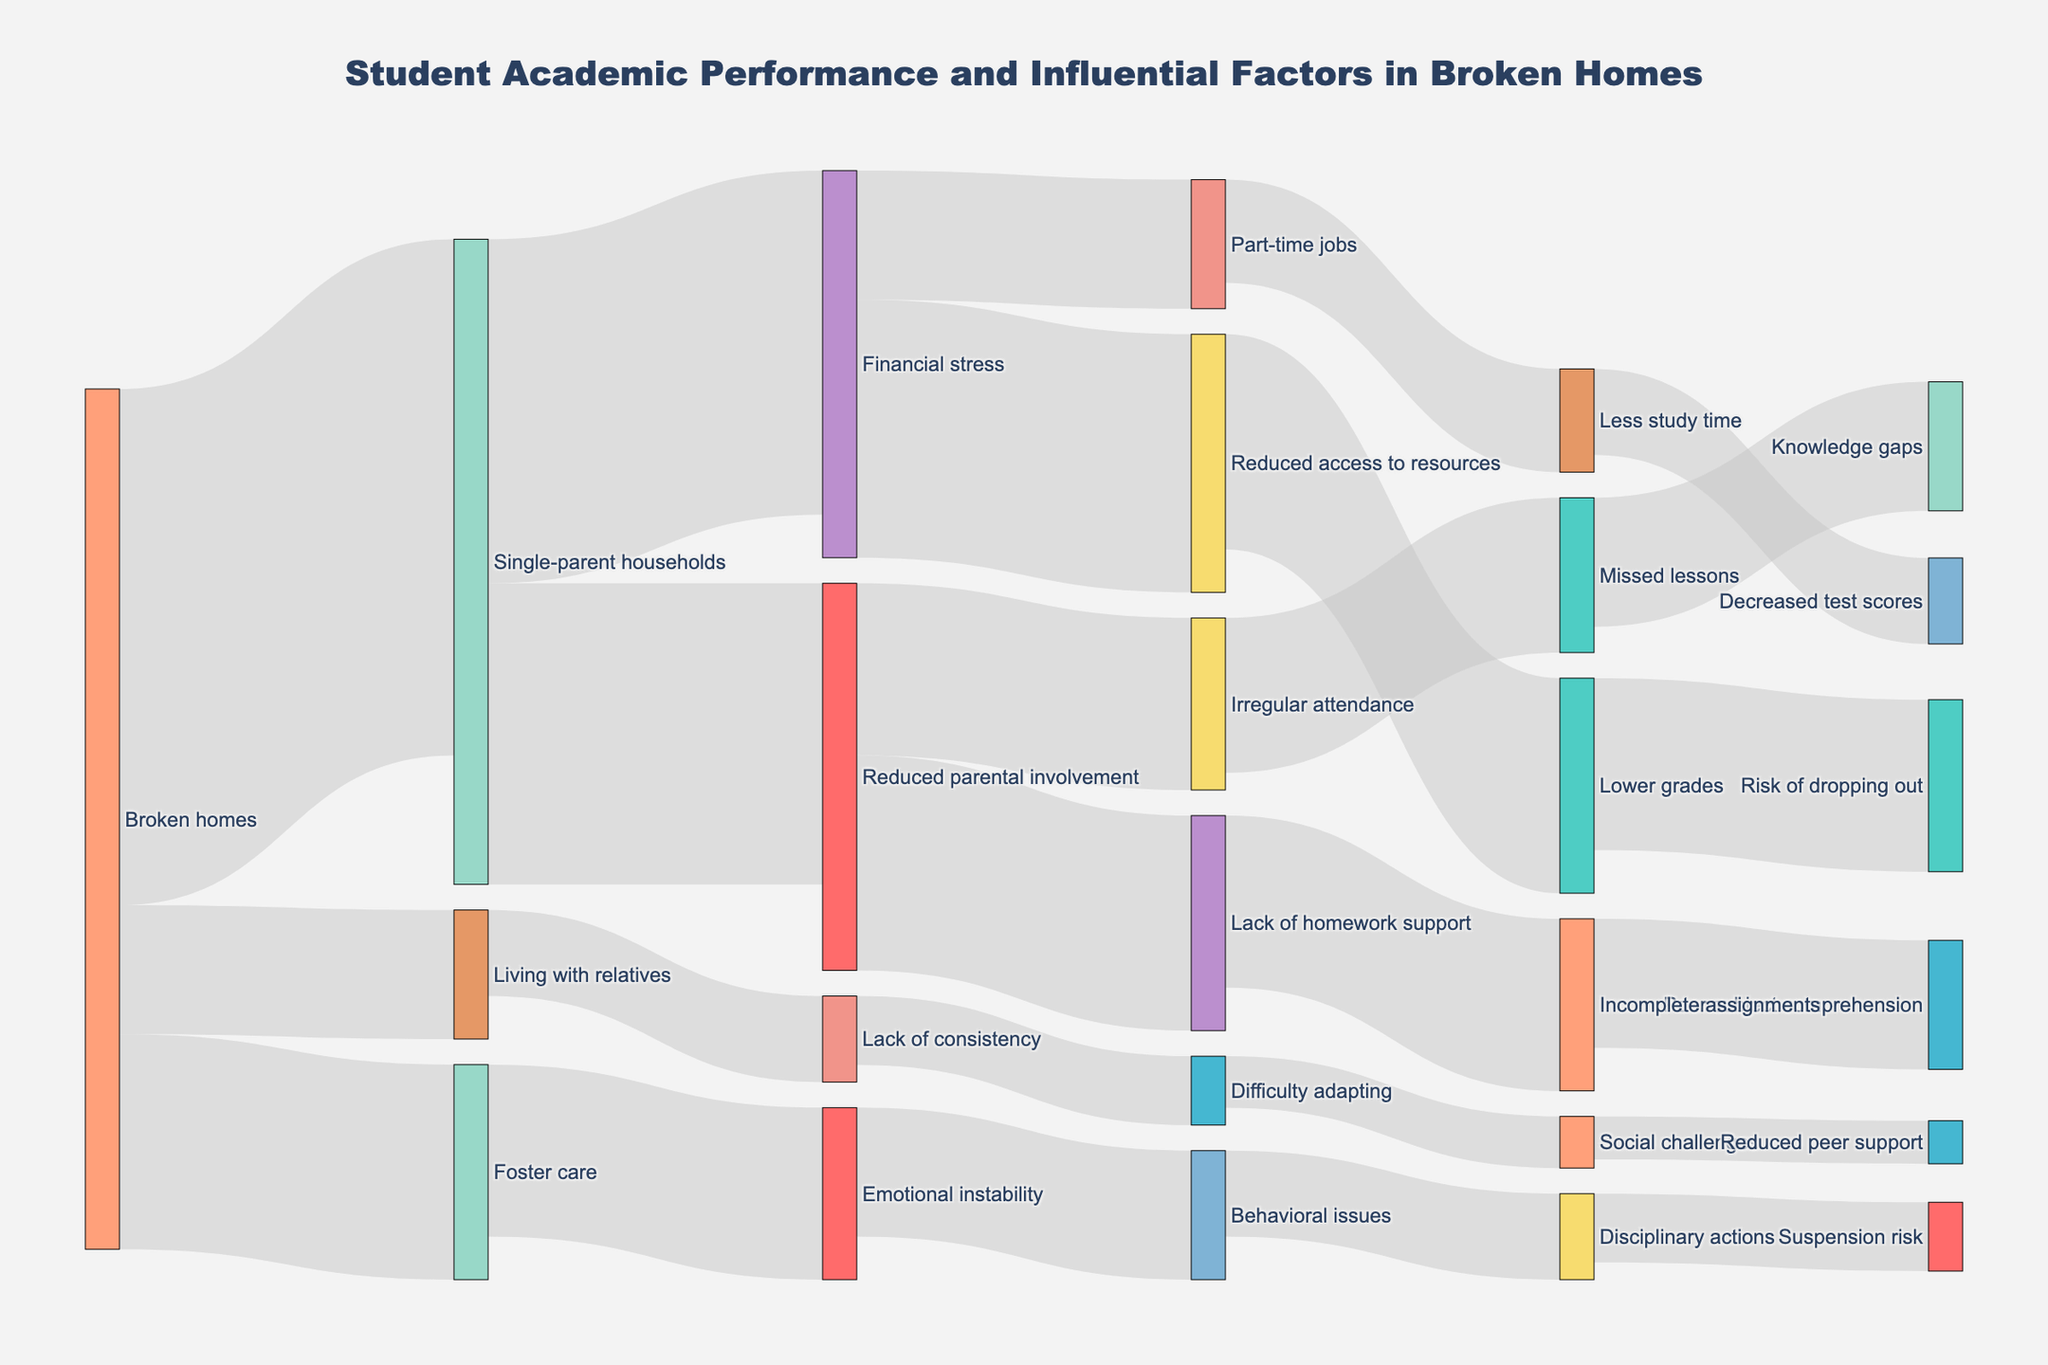What is the title of the figure? The title is displayed at the top center of the figure, indicating the main topic of the Sankey Diagram. The title reads "Student Academic Performance and Influential Factors in Broken Homes"
Answer: Student Academic Performance and Influential Factors in Broken Homes How many nodes are related to financial stress? By examining the nodes connected to 'Financial stress', we see two links: one to 'Reduced access to resources' and another to 'Part-time jobs'.
Answer: Two nodes Which factor originating from broken homes has the highest value? By visual inspection of the values connected directly to 'Broken homes', we observe that 'Single-parent households' has the highest value of 60.
Answer: Single-parent households What total value is associated with 'Reduced parental involvement'? Sum the values of links coming out from 'Reduced parental involvement': 'Lack of homework support' (25) and 'Irregular attendance' (20), giving a total of 25 + 20 = 45.
Answer: 45 What are the direct consequences of financial stress? The Sankey Diagram shows links from 'Financial stress' to 'Reduced access to resources' and 'Part-time jobs'.
Answer: Reduced access to resources, Part-time jobs Out of 'Lack of homework support' and 'Incomplete assignments', which has a higher value? By comparing the values, 'Lack of homework support' has a value of 25, and 'Incomplete assignments' has a value of 20; thus, 'Lack of homework support' has a higher value.
Answer: Lack of homework support What is the combined value of issues related to emotional instability and behavioral issues? The values are: 'Emotional instability' (20), 'Behavioral issues' (15). Summing these gives 20 + 15 = 35.
Answer: 35 Which outcome has the least value among the nodes associated with ‘Single-parent households’? Check the values of the nodes connected to 'Single-parent households': 'Financial stress' (40) and 'Reduced parental involvement' (35). 'Reduced parental involvement' with a value of 35 is the lesser.
Answer: Reduced parental involvement Which node has the highest number of connections? Count the connections for each node. 'Broken homes' has four, which is the highest number of connections among all nodes.
Answer: Broken homes Which pathway results in a risk of dropping out? Trace the connection leading to 'Risk of dropping out'. It originates from 'Lower grades', which comes from 'Reduced access to resources', connected to 'Financial stress' from 'Single-parent households'. Thus, a path leading to 'Risk of dropping out' is: 'Single-parent households' → 'Financial stress' → 'Reduced access to resources' → 'Lower grades' → 'Risk of dropping out'.
Answer: Financial stress to reduced access to resources to lower grades 